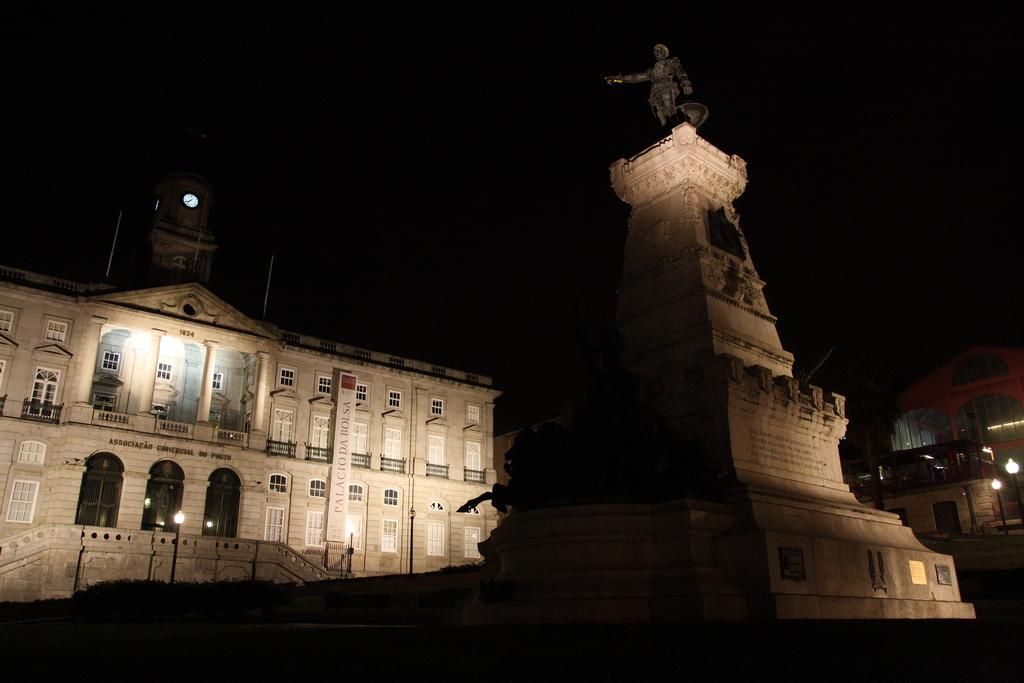What is the main subject in the image? There is a statue in the image. What other structures can be seen in the image? There is a building in the image. What architectural feature is present on the building? There are windows in the image. What time-related object is visible in the image? There is a clock in the image. What type of salt is being used to season the food in the image? There is no food or salt present in the image; it features a statue, a building, windows, and a clock. 